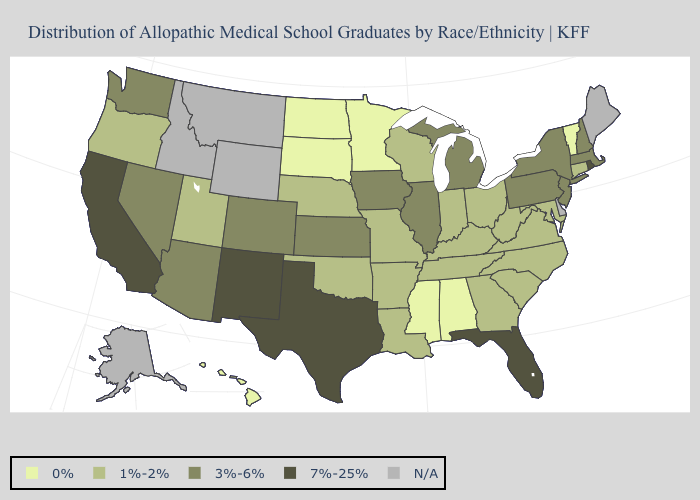What is the lowest value in states that border Maine?
Answer briefly. 3%-6%. Does Vermont have the lowest value in the USA?
Concise answer only. Yes. Name the states that have a value in the range 0%?
Quick response, please. Alabama, Hawaii, Minnesota, Mississippi, North Dakota, South Dakota, Vermont. Does the map have missing data?
Concise answer only. Yes. Is the legend a continuous bar?
Give a very brief answer. No. What is the value of California?
Give a very brief answer. 7%-25%. What is the highest value in the Northeast ?
Keep it brief. 7%-25%. Which states hav the highest value in the West?
Quick response, please. California, New Mexico. Which states have the highest value in the USA?
Short answer required. California, Florida, New Mexico, Rhode Island, Texas. Name the states that have a value in the range 3%-6%?
Be succinct. Arizona, Colorado, Illinois, Iowa, Kansas, Massachusetts, Michigan, Nevada, New Hampshire, New Jersey, New York, Pennsylvania, Washington. Which states have the highest value in the USA?
Answer briefly. California, Florida, New Mexico, Rhode Island, Texas. Does Georgia have the highest value in the South?
Write a very short answer. No. Name the states that have a value in the range 7%-25%?
Write a very short answer. California, Florida, New Mexico, Rhode Island, Texas. What is the highest value in the USA?
Quick response, please. 7%-25%. 